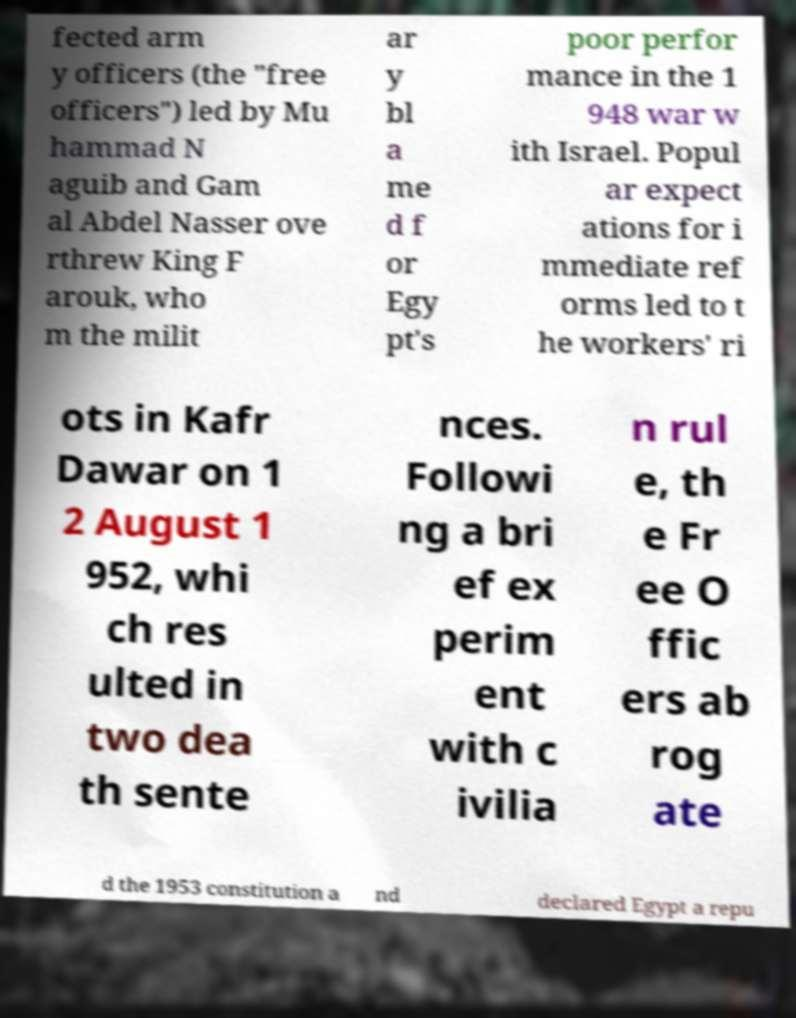There's text embedded in this image that I need extracted. Can you transcribe it verbatim? fected arm y officers (the "free officers") led by Mu hammad N aguib and Gam al Abdel Nasser ove rthrew King F arouk, who m the milit ar y bl a me d f or Egy pt's poor perfor mance in the 1 948 war w ith Israel. Popul ar expect ations for i mmediate ref orms led to t he workers' ri ots in Kafr Dawar on 1 2 August 1 952, whi ch res ulted in two dea th sente nces. Followi ng a bri ef ex perim ent with c ivilia n rul e, th e Fr ee O ffic ers ab rog ate d the 1953 constitution a nd declared Egypt a repu 